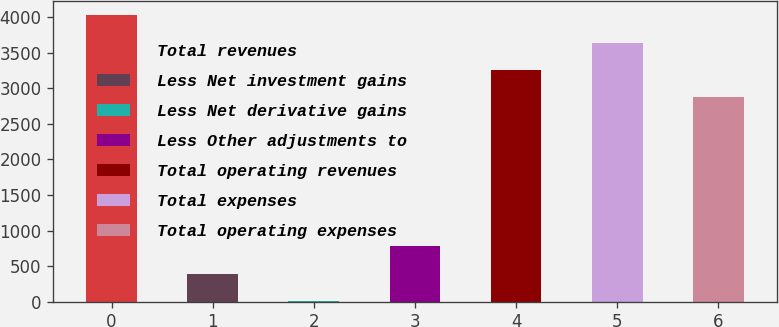Convert chart. <chart><loc_0><loc_0><loc_500><loc_500><bar_chart><fcel>Total revenues<fcel>Less Net investment gains<fcel>Less Net derivative gains<fcel>Less Other adjustments to<fcel>Total operating revenues<fcel>Total expenses<fcel>Total operating expenses<nl><fcel>4030.4<fcel>391.8<fcel>6<fcel>777.6<fcel>3258.8<fcel>3644.6<fcel>2873<nl></chart> 